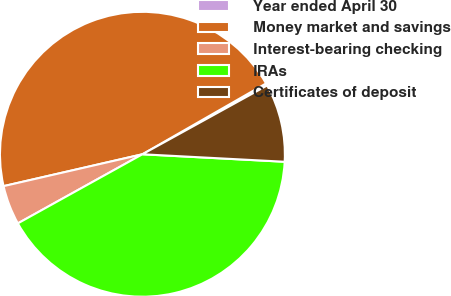Convert chart to OTSL. <chart><loc_0><loc_0><loc_500><loc_500><pie_chart><fcel>Year ended April 30<fcel>Money market and savings<fcel>Interest-bearing checking<fcel>IRAs<fcel>Certificates of deposit<nl><fcel>0.26%<fcel>45.31%<fcel>4.47%<fcel>41.1%<fcel>8.86%<nl></chart> 